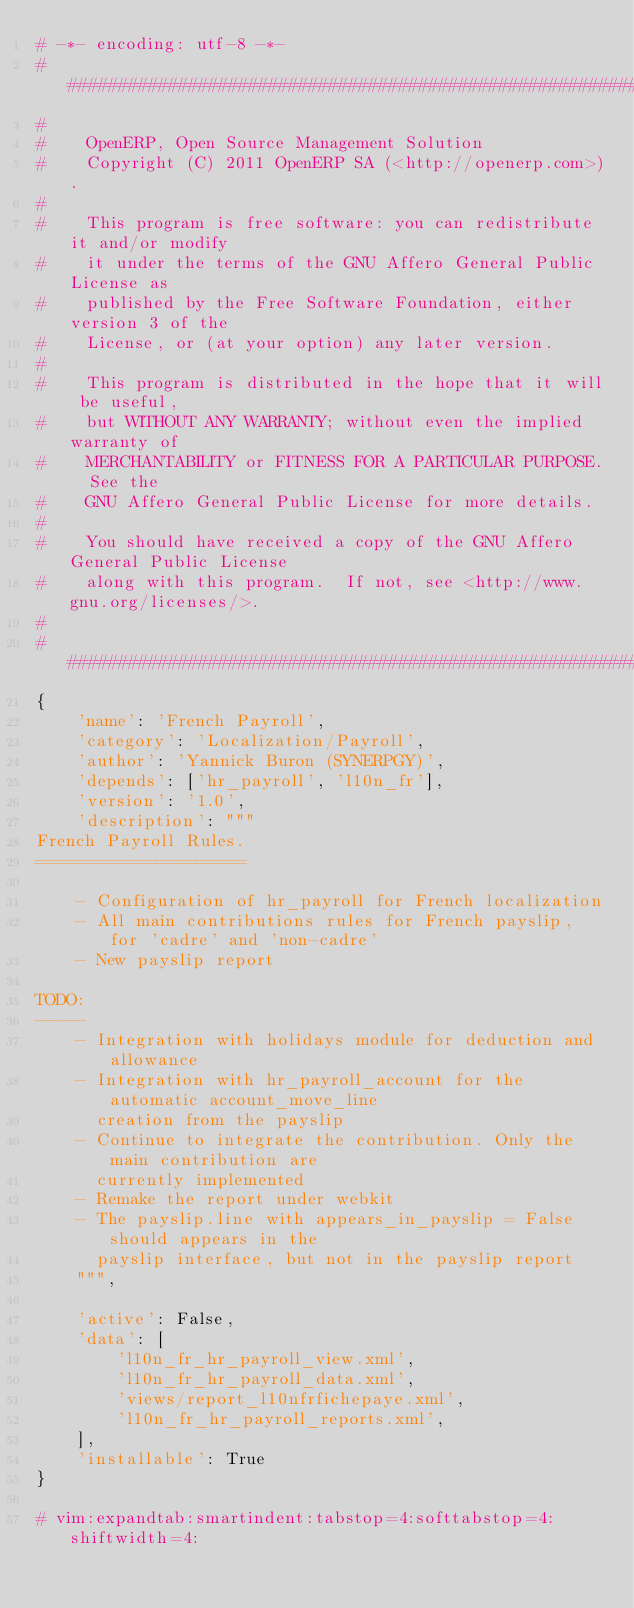Convert code to text. <code><loc_0><loc_0><loc_500><loc_500><_Python_># -*- encoding: utf-8 -*-
##############################################################################
#
#    OpenERP, Open Source Management Solution
#    Copyright (C) 2011 OpenERP SA (<http://openerp.com>).
#
#    This program is free software: you can redistribute it and/or modify
#    it under the terms of the GNU Affero General Public License as
#    published by the Free Software Foundation, either version 3 of the
#    License, or (at your option) any later version.
#
#    This program is distributed in the hope that it will be useful,
#    but WITHOUT ANY WARRANTY; without even the implied warranty of
#    MERCHANTABILITY or FITNESS FOR A PARTICULAR PURPOSE.  See the
#    GNU Affero General Public License for more details.
#
#    You should have received a copy of the GNU Affero General Public License
#    along with this program.  If not, see <http://www.gnu.org/licenses/>.
#
##############################################################################
{
    'name': 'French Payroll',
    'category': 'Localization/Payroll',
    'author': 'Yannick Buron (SYNERPGY)',
    'depends': ['hr_payroll', 'l10n_fr'],
    'version': '1.0',
    'description': """
French Payroll Rules.
=====================

    - Configuration of hr_payroll for French localization
    - All main contributions rules for French payslip, for 'cadre' and 'non-cadre'
    - New payslip report

TODO:
-----
    - Integration with holidays module for deduction and allowance
    - Integration with hr_payroll_account for the automatic account_move_line
      creation from the payslip
    - Continue to integrate the contribution. Only the main contribution are
      currently implemented
    - Remake the report under webkit
    - The payslip.line with appears_in_payslip = False should appears in the
      payslip interface, but not in the payslip report
    """,

    'active': False,
    'data': [
        'l10n_fr_hr_payroll_view.xml',
        'l10n_fr_hr_payroll_data.xml',
        'views/report_l10nfrfichepaye.xml',
        'l10n_fr_hr_payroll_reports.xml',
    ],
    'installable': True
}

# vim:expandtab:smartindent:tabstop=4:softtabstop=4:shiftwidth=4:
</code> 